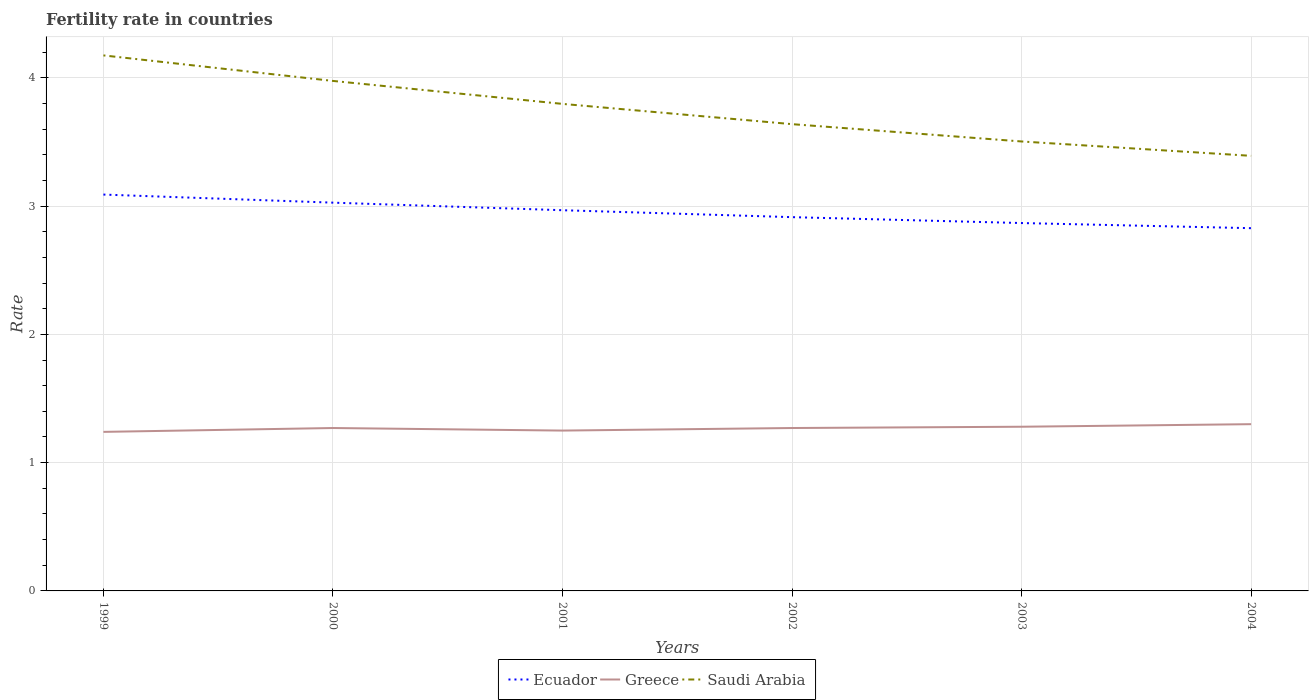Across all years, what is the maximum fertility rate in Ecuador?
Offer a very short reply. 2.83. What is the total fertility rate in Saudi Arabia in the graph?
Offer a terse response. 0.58. What is the difference between the highest and the second highest fertility rate in Ecuador?
Make the answer very short. 0.26. Is the fertility rate in Greece strictly greater than the fertility rate in Ecuador over the years?
Provide a short and direct response. Yes. How many years are there in the graph?
Ensure brevity in your answer.  6. Does the graph contain grids?
Offer a very short reply. Yes. Where does the legend appear in the graph?
Your response must be concise. Bottom center. What is the title of the graph?
Keep it short and to the point. Fertility rate in countries. Does "Afghanistan" appear as one of the legend labels in the graph?
Ensure brevity in your answer.  No. What is the label or title of the Y-axis?
Make the answer very short. Rate. What is the Rate in Ecuador in 1999?
Offer a very short reply. 3.09. What is the Rate in Greece in 1999?
Offer a terse response. 1.24. What is the Rate in Saudi Arabia in 1999?
Your answer should be compact. 4.17. What is the Rate in Ecuador in 2000?
Ensure brevity in your answer.  3.03. What is the Rate of Greece in 2000?
Give a very brief answer. 1.27. What is the Rate in Saudi Arabia in 2000?
Ensure brevity in your answer.  3.98. What is the Rate in Ecuador in 2001?
Keep it short and to the point. 2.97. What is the Rate of Greece in 2001?
Offer a very short reply. 1.25. What is the Rate in Saudi Arabia in 2001?
Your response must be concise. 3.8. What is the Rate of Ecuador in 2002?
Give a very brief answer. 2.91. What is the Rate in Greece in 2002?
Make the answer very short. 1.27. What is the Rate of Saudi Arabia in 2002?
Make the answer very short. 3.64. What is the Rate in Ecuador in 2003?
Make the answer very short. 2.87. What is the Rate of Greece in 2003?
Make the answer very short. 1.28. What is the Rate in Saudi Arabia in 2003?
Offer a very short reply. 3.5. What is the Rate in Ecuador in 2004?
Provide a short and direct response. 2.83. What is the Rate in Saudi Arabia in 2004?
Make the answer very short. 3.39. Across all years, what is the maximum Rate of Ecuador?
Your answer should be compact. 3.09. Across all years, what is the maximum Rate of Greece?
Give a very brief answer. 1.3. Across all years, what is the maximum Rate of Saudi Arabia?
Your response must be concise. 4.17. Across all years, what is the minimum Rate in Ecuador?
Provide a short and direct response. 2.83. Across all years, what is the minimum Rate in Greece?
Provide a short and direct response. 1.24. Across all years, what is the minimum Rate of Saudi Arabia?
Make the answer very short. 3.39. What is the total Rate of Ecuador in the graph?
Make the answer very short. 17.7. What is the total Rate in Greece in the graph?
Provide a short and direct response. 7.61. What is the total Rate of Saudi Arabia in the graph?
Provide a short and direct response. 22.48. What is the difference between the Rate of Ecuador in 1999 and that in 2000?
Your response must be concise. 0.06. What is the difference between the Rate of Greece in 1999 and that in 2000?
Offer a very short reply. -0.03. What is the difference between the Rate of Saudi Arabia in 1999 and that in 2000?
Give a very brief answer. 0.2. What is the difference between the Rate in Ecuador in 1999 and that in 2001?
Provide a short and direct response. 0.12. What is the difference between the Rate of Greece in 1999 and that in 2001?
Ensure brevity in your answer.  -0.01. What is the difference between the Rate of Saudi Arabia in 1999 and that in 2001?
Offer a very short reply. 0.38. What is the difference between the Rate of Ecuador in 1999 and that in 2002?
Your answer should be compact. 0.18. What is the difference between the Rate in Greece in 1999 and that in 2002?
Offer a terse response. -0.03. What is the difference between the Rate in Saudi Arabia in 1999 and that in 2002?
Provide a succinct answer. 0.54. What is the difference between the Rate of Ecuador in 1999 and that in 2003?
Your answer should be very brief. 0.22. What is the difference between the Rate in Greece in 1999 and that in 2003?
Keep it short and to the point. -0.04. What is the difference between the Rate of Saudi Arabia in 1999 and that in 2003?
Give a very brief answer. 0.67. What is the difference between the Rate in Ecuador in 1999 and that in 2004?
Give a very brief answer. 0.26. What is the difference between the Rate of Greece in 1999 and that in 2004?
Provide a short and direct response. -0.06. What is the difference between the Rate in Saudi Arabia in 1999 and that in 2004?
Keep it short and to the point. 0.78. What is the difference between the Rate in Ecuador in 2000 and that in 2001?
Offer a very short reply. 0.06. What is the difference between the Rate of Saudi Arabia in 2000 and that in 2001?
Make the answer very short. 0.18. What is the difference between the Rate of Ecuador in 2000 and that in 2002?
Offer a very short reply. 0.11. What is the difference between the Rate in Greece in 2000 and that in 2002?
Your response must be concise. 0. What is the difference between the Rate in Saudi Arabia in 2000 and that in 2002?
Your response must be concise. 0.34. What is the difference between the Rate of Ecuador in 2000 and that in 2003?
Provide a short and direct response. 0.16. What is the difference between the Rate in Greece in 2000 and that in 2003?
Provide a succinct answer. -0.01. What is the difference between the Rate in Saudi Arabia in 2000 and that in 2003?
Your answer should be compact. 0.47. What is the difference between the Rate in Ecuador in 2000 and that in 2004?
Provide a short and direct response. 0.2. What is the difference between the Rate in Greece in 2000 and that in 2004?
Provide a short and direct response. -0.03. What is the difference between the Rate in Saudi Arabia in 2000 and that in 2004?
Keep it short and to the point. 0.58. What is the difference between the Rate of Ecuador in 2001 and that in 2002?
Give a very brief answer. 0.05. What is the difference between the Rate of Greece in 2001 and that in 2002?
Provide a short and direct response. -0.02. What is the difference between the Rate of Saudi Arabia in 2001 and that in 2002?
Offer a very short reply. 0.16. What is the difference between the Rate in Ecuador in 2001 and that in 2003?
Keep it short and to the point. 0.1. What is the difference between the Rate of Greece in 2001 and that in 2003?
Keep it short and to the point. -0.03. What is the difference between the Rate of Saudi Arabia in 2001 and that in 2003?
Keep it short and to the point. 0.29. What is the difference between the Rate in Ecuador in 2001 and that in 2004?
Make the answer very short. 0.14. What is the difference between the Rate of Saudi Arabia in 2001 and that in 2004?
Offer a very short reply. 0.41. What is the difference between the Rate of Ecuador in 2002 and that in 2003?
Your answer should be very brief. 0.05. What is the difference between the Rate in Greece in 2002 and that in 2003?
Provide a short and direct response. -0.01. What is the difference between the Rate in Saudi Arabia in 2002 and that in 2003?
Provide a short and direct response. 0.14. What is the difference between the Rate in Ecuador in 2002 and that in 2004?
Provide a short and direct response. 0.09. What is the difference between the Rate in Greece in 2002 and that in 2004?
Your answer should be compact. -0.03. What is the difference between the Rate of Saudi Arabia in 2002 and that in 2004?
Make the answer very short. 0.25. What is the difference between the Rate of Ecuador in 2003 and that in 2004?
Your response must be concise. 0.04. What is the difference between the Rate of Greece in 2003 and that in 2004?
Provide a short and direct response. -0.02. What is the difference between the Rate of Saudi Arabia in 2003 and that in 2004?
Offer a very short reply. 0.11. What is the difference between the Rate in Ecuador in 1999 and the Rate in Greece in 2000?
Make the answer very short. 1.82. What is the difference between the Rate in Ecuador in 1999 and the Rate in Saudi Arabia in 2000?
Keep it short and to the point. -0.89. What is the difference between the Rate of Greece in 1999 and the Rate of Saudi Arabia in 2000?
Give a very brief answer. -2.74. What is the difference between the Rate in Ecuador in 1999 and the Rate in Greece in 2001?
Your response must be concise. 1.84. What is the difference between the Rate in Ecuador in 1999 and the Rate in Saudi Arabia in 2001?
Your response must be concise. -0.71. What is the difference between the Rate in Greece in 1999 and the Rate in Saudi Arabia in 2001?
Give a very brief answer. -2.56. What is the difference between the Rate in Ecuador in 1999 and the Rate in Greece in 2002?
Provide a succinct answer. 1.82. What is the difference between the Rate of Ecuador in 1999 and the Rate of Saudi Arabia in 2002?
Offer a terse response. -0.55. What is the difference between the Rate of Greece in 1999 and the Rate of Saudi Arabia in 2002?
Ensure brevity in your answer.  -2.4. What is the difference between the Rate of Ecuador in 1999 and the Rate of Greece in 2003?
Keep it short and to the point. 1.81. What is the difference between the Rate in Ecuador in 1999 and the Rate in Saudi Arabia in 2003?
Ensure brevity in your answer.  -0.41. What is the difference between the Rate of Greece in 1999 and the Rate of Saudi Arabia in 2003?
Make the answer very short. -2.26. What is the difference between the Rate in Ecuador in 1999 and the Rate in Greece in 2004?
Your response must be concise. 1.79. What is the difference between the Rate of Ecuador in 1999 and the Rate of Saudi Arabia in 2004?
Provide a succinct answer. -0.3. What is the difference between the Rate of Greece in 1999 and the Rate of Saudi Arabia in 2004?
Your response must be concise. -2.15. What is the difference between the Rate in Ecuador in 2000 and the Rate in Greece in 2001?
Provide a succinct answer. 1.78. What is the difference between the Rate of Ecuador in 2000 and the Rate of Saudi Arabia in 2001?
Your answer should be compact. -0.77. What is the difference between the Rate of Greece in 2000 and the Rate of Saudi Arabia in 2001?
Offer a terse response. -2.53. What is the difference between the Rate of Ecuador in 2000 and the Rate of Greece in 2002?
Ensure brevity in your answer.  1.76. What is the difference between the Rate of Ecuador in 2000 and the Rate of Saudi Arabia in 2002?
Provide a succinct answer. -0.61. What is the difference between the Rate of Greece in 2000 and the Rate of Saudi Arabia in 2002?
Make the answer very short. -2.37. What is the difference between the Rate of Ecuador in 2000 and the Rate of Greece in 2003?
Your response must be concise. 1.75. What is the difference between the Rate of Ecuador in 2000 and the Rate of Saudi Arabia in 2003?
Keep it short and to the point. -0.48. What is the difference between the Rate in Greece in 2000 and the Rate in Saudi Arabia in 2003?
Ensure brevity in your answer.  -2.23. What is the difference between the Rate of Ecuador in 2000 and the Rate of Greece in 2004?
Provide a succinct answer. 1.73. What is the difference between the Rate in Ecuador in 2000 and the Rate in Saudi Arabia in 2004?
Keep it short and to the point. -0.36. What is the difference between the Rate of Greece in 2000 and the Rate of Saudi Arabia in 2004?
Your answer should be compact. -2.12. What is the difference between the Rate in Ecuador in 2001 and the Rate in Greece in 2002?
Your answer should be compact. 1.7. What is the difference between the Rate in Ecuador in 2001 and the Rate in Saudi Arabia in 2002?
Your answer should be very brief. -0.67. What is the difference between the Rate of Greece in 2001 and the Rate of Saudi Arabia in 2002?
Make the answer very short. -2.39. What is the difference between the Rate in Ecuador in 2001 and the Rate in Greece in 2003?
Give a very brief answer. 1.69. What is the difference between the Rate of Ecuador in 2001 and the Rate of Saudi Arabia in 2003?
Make the answer very short. -0.54. What is the difference between the Rate of Greece in 2001 and the Rate of Saudi Arabia in 2003?
Keep it short and to the point. -2.25. What is the difference between the Rate in Ecuador in 2001 and the Rate in Greece in 2004?
Your answer should be compact. 1.67. What is the difference between the Rate in Ecuador in 2001 and the Rate in Saudi Arabia in 2004?
Offer a very short reply. -0.42. What is the difference between the Rate in Greece in 2001 and the Rate in Saudi Arabia in 2004?
Make the answer very short. -2.14. What is the difference between the Rate in Ecuador in 2002 and the Rate in Greece in 2003?
Make the answer very short. 1.63. What is the difference between the Rate in Ecuador in 2002 and the Rate in Saudi Arabia in 2003?
Offer a terse response. -0.59. What is the difference between the Rate of Greece in 2002 and the Rate of Saudi Arabia in 2003?
Keep it short and to the point. -2.23. What is the difference between the Rate in Ecuador in 2002 and the Rate in Greece in 2004?
Make the answer very short. 1.61. What is the difference between the Rate of Ecuador in 2002 and the Rate of Saudi Arabia in 2004?
Give a very brief answer. -0.48. What is the difference between the Rate of Greece in 2002 and the Rate of Saudi Arabia in 2004?
Your answer should be compact. -2.12. What is the difference between the Rate in Ecuador in 2003 and the Rate in Greece in 2004?
Give a very brief answer. 1.57. What is the difference between the Rate in Ecuador in 2003 and the Rate in Saudi Arabia in 2004?
Provide a succinct answer. -0.52. What is the difference between the Rate of Greece in 2003 and the Rate of Saudi Arabia in 2004?
Offer a terse response. -2.11. What is the average Rate in Ecuador per year?
Your answer should be compact. 2.95. What is the average Rate in Greece per year?
Your answer should be very brief. 1.27. What is the average Rate in Saudi Arabia per year?
Ensure brevity in your answer.  3.75. In the year 1999, what is the difference between the Rate of Ecuador and Rate of Greece?
Offer a terse response. 1.85. In the year 1999, what is the difference between the Rate in Ecuador and Rate in Saudi Arabia?
Ensure brevity in your answer.  -1.08. In the year 1999, what is the difference between the Rate in Greece and Rate in Saudi Arabia?
Keep it short and to the point. -2.94. In the year 2000, what is the difference between the Rate in Ecuador and Rate in Greece?
Give a very brief answer. 1.76. In the year 2000, what is the difference between the Rate of Ecuador and Rate of Saudi Arabia?
Make the answer very short. -0.95. In the year 2000, what is the difference between the Rate in Greece and Rate in Saudi Arabia?
Ensure brevity in your answer.  -2.71. In the year 2001, what is the difference between the Rate of Ecuador and Rate of Greece?
Provide a succinct answer. 1.72. In the year 2001, what is the difference between the Rate of Ecuador and Rate of Saudi Arabia?
Your response must be concise. -0.83. In the year 2001, what is the difference between the Rate of Greece and Rate of Saudi Arabia?
Make the answer very short. -2.55. In the year 2002, what is the difference between the Rate in Ecuador and Rate in Greece?
Provide a short and direct response. 1.64. In the year 2002, what is the difference between the Rate in Ecuador and Rate in Saudi Arabia?
Ensure brevity in your answer.  -0.72. In the year 2002, what is the difference between the Rate in Greece and Rate in Saudi Arabia?
Your answer should be compact. -2.37. In the year 2003, what is the difference between the Rate in Ecuador and Rate in Greece?
Offer a terse response. 1.59. In the year 2003, what is the difference between the Rate of Ecuador and Rate of Saudi Arabia?
Provide a succinct answer. -0.64. In the year 2003, what is the difference between the Rate in Greece and Rate in Saudi Arabia?
Your response must be concise. -2.22. In the year 2004, what is the difference between the Rate of Ecuador and Rate of Greece?
Offer a terse response. 1.53. In the year 2004, what is the difference between the Rate of Ecuador and Rate of Saudi Arabia?
Ensure brevity in your answer.  -0.56. In the year 2004, what is the difference between the Rate in Greece and Rate in Saudi Arabia?
Your response must be concise. -2.09. What is the ratio of the Rate in Ecuador in 1999 to that in 2000?
Your answer should be very brief. 1.02. What is the ratio of the Rate of Greece in 1999 to that in 2000?
Your response must be concise. 0.98. What is the ratio of the Rate of Saudi Arabia in 1999 to that in 2000?
Keep it short and to the point. 1.05. What is the ratio of the Rate of Ecuador in 1999 to that in 2001?
Provide a short and direct response. 1.04. What is the ratio of the Rate of Saudi Arabia in 1999 to that in 2001?
Your answer should be very brief. 1.1. What is the ratio of the Rate in Ecuador in 1999 to that in 2002?
Offer a terse response. 1.06. What is the ratio of the Rate in Greece in 1999 to that in 2002?
Offer a very short reply. 0.98. What is the ratio of the Rate in Saudi Arabia in 1999 to that in 2002?
Your response must be concise. 1.15. What is the ratio of the Rate in Ecuador in 1999 to that in 2003?
Make the answer very short. 1.08. What is the ratio of the Rate in Greece in 1999 to that in 2003?
Give a very brief answer. 0.97. What is the ratio of the Rate in Saudi Arabia in 1999 to that in 2003?
Offer a very short reply. 1.19. What is the ratio of the Rate in Ecuador in 1999 to that in 2004?
Ensure brevity in your answer.  1.09. What is the ratio of the Rate in Greece in 1999 to that in 2004?
Your answer should be very brief. 0.95. What is the ratio of the Rate in Saudi Arabia in 1999 to that in 2004?
Provide a short and direct response. 1.23. What is the ratio of the Rate in Ecuador in 2000 to that in 2001?
Ensure brevity in your answer.  1.02. What is the ratio of the Rate of Saudi Arabia in 2000 to that in 2001?
Offer a terse response. 1.05. What is the ratio of the Rate of Ecuador in 2000 to that in 2002?
Your response must be concise. 1.04. What is the ratio of the Rate of Greece in 2000 to that in 2002?
Your answer should be compact. 1. What is the ratio of the Rate in Saudi Arabia in 2000 to that in 2002?
Ensure brevity in your answer.  1.09. What is the ratio of the Rate in Ecuador in 2000 to that in 2003?
Make the answer very short. 1.06. What is the ratio of the Rate of Greece in 2000 to that in 2003?
Offer a terse response. 0.99. What is the ratio of the Rate in Saudi Arabia in 2000 to that in 2003?
Keep it short and to the point. 1.13. What is the ratio of the Rate in Ecuador in 2000 to that in 2004?
Offer a very short reply. 1.07. What is the ratio of the Rate in Greece in 2000 to that in 2004?
Provide a succinct answer. 0.98. What is the ratio of the Rate of Saudi Arabia in 2000 to that in 2004?
Ensure brevity in your answer.  1.17. What is the ratio of the Rate in Ecuador in 2001 to that in 2002?
Ensure brevity in your answer.  1.02. What is the ratio of the Rate in Greece in 2001 to that in 2002?
Your answer should be very brief. 0.98. What is the ratio of the Rate of Saudi Arabia in 2001 to that in 2002?
Provide a short and direct response. 1.04. What is the ratio of the Rate in Ecuador in 2001 to that in 2003?
Your answer should be compact. 1.03. What is the ratio of the Rate in Greece in 2001 to that in 2003?
Make the answer very short. 0.98. What is the ratio of the Rate of Saudi Arabia in 2001 to that in 2003?
Your response must be concise. 1.08. What is the ratio of the Rate in Ecuador in 2001 to that in 2004?
Offer a terse response. 1.05. What is the ratio of the Rate in Greece in 2001 to that in 2004?
Your response must be concise. 0.96. What is the ratio of the Rate of Saudi Arabia in 2001 to that in 2004?
Your answer should be very brief. 1.12. What is the ratio of the Rate of Ecuador in 2002 to that in 2004?
Your answer should be compact. 1.03. What is the ratio of the Rate of Greece in 2002 to that in 2004?
Offer a terse response. 0.98. What is the ratio of the Rate of Saudi Arabia in 2002 to that in 2004?
Your response must be concise. 1.07. What is the ratio of the Rate of Ecuador in 2003 to that in 2004?
Make the answer very short. 1.01. What is the ratio of the Rate of Greece in 2003 to that in 2004?
Ensure brevity in your answer.  0.98. What is the ratio of the Rate in Saudi Arabia in 2003 to that in 2004?
Ensure brevity in your answer.  1.03. What is the difference between the highest and the second highest Rate of Ecuador?
Give a very brief answer. 0.06. What is the difference between the highest and the second highest Rate of Saudi Arabia?
Give a very brief answer. 0.2. What is the difference between the highest and the lowest Rate of Ecuador?
Offer a terse response. 0.26. What is the difference between the highest and the lowest Rate in Greece?
Give a very brief answer. 0.06. What is the difference between the highest and the lowest Rate in Saudi Arabia?
Provide a short and direct response. 0.78. 